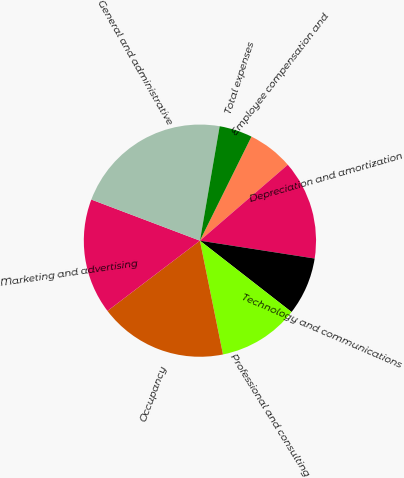Convert chart. <chart><loc_0><loc_0><loc_500><loc_500><pie_chart><fcel>Employee compensation and<fcel>Depreciation and amortization<fcel>Technology and communications<fcel>Professional and consulting<fcel>Occupancy<fcel>Marketing and advertising<fcel>General and administrative<fcel>Total expenses<nl><fcel>6.34%<fcel>13.8%<fcel>8.07%<fcel>11.29%<fcel>17.84%<fcel>16.1%<fcel>21.96%<fcel>4.6%<nl></chart> 